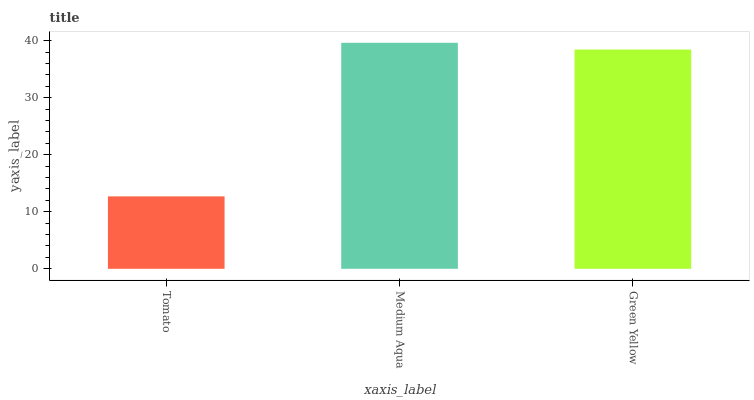Is Green Yellow the minimum?
Answer yes or no. No. Is Green Yellow the maximum?
Answer yes or no. No. Is Medium Aqua greater than Green Yellow?
Answer yes or no. Yes. Is Green Yellow less than Medium Aqua?
Answer yes or no. Yes. Is Green Yellow greater than Medium Aqua?
Answer yes or no. No. Is Medium Aqua less than Green Yellow?
Answer yes or no. No. Is Green Yellow the high median?
Answer yes or no. Yes. Is Green Yellow the low median?
Answer yes or no. Yes. Is Medium Aqua the high median?
Answer yes or no. No. Is Tomato the low median?
Answer yes or no. No. 